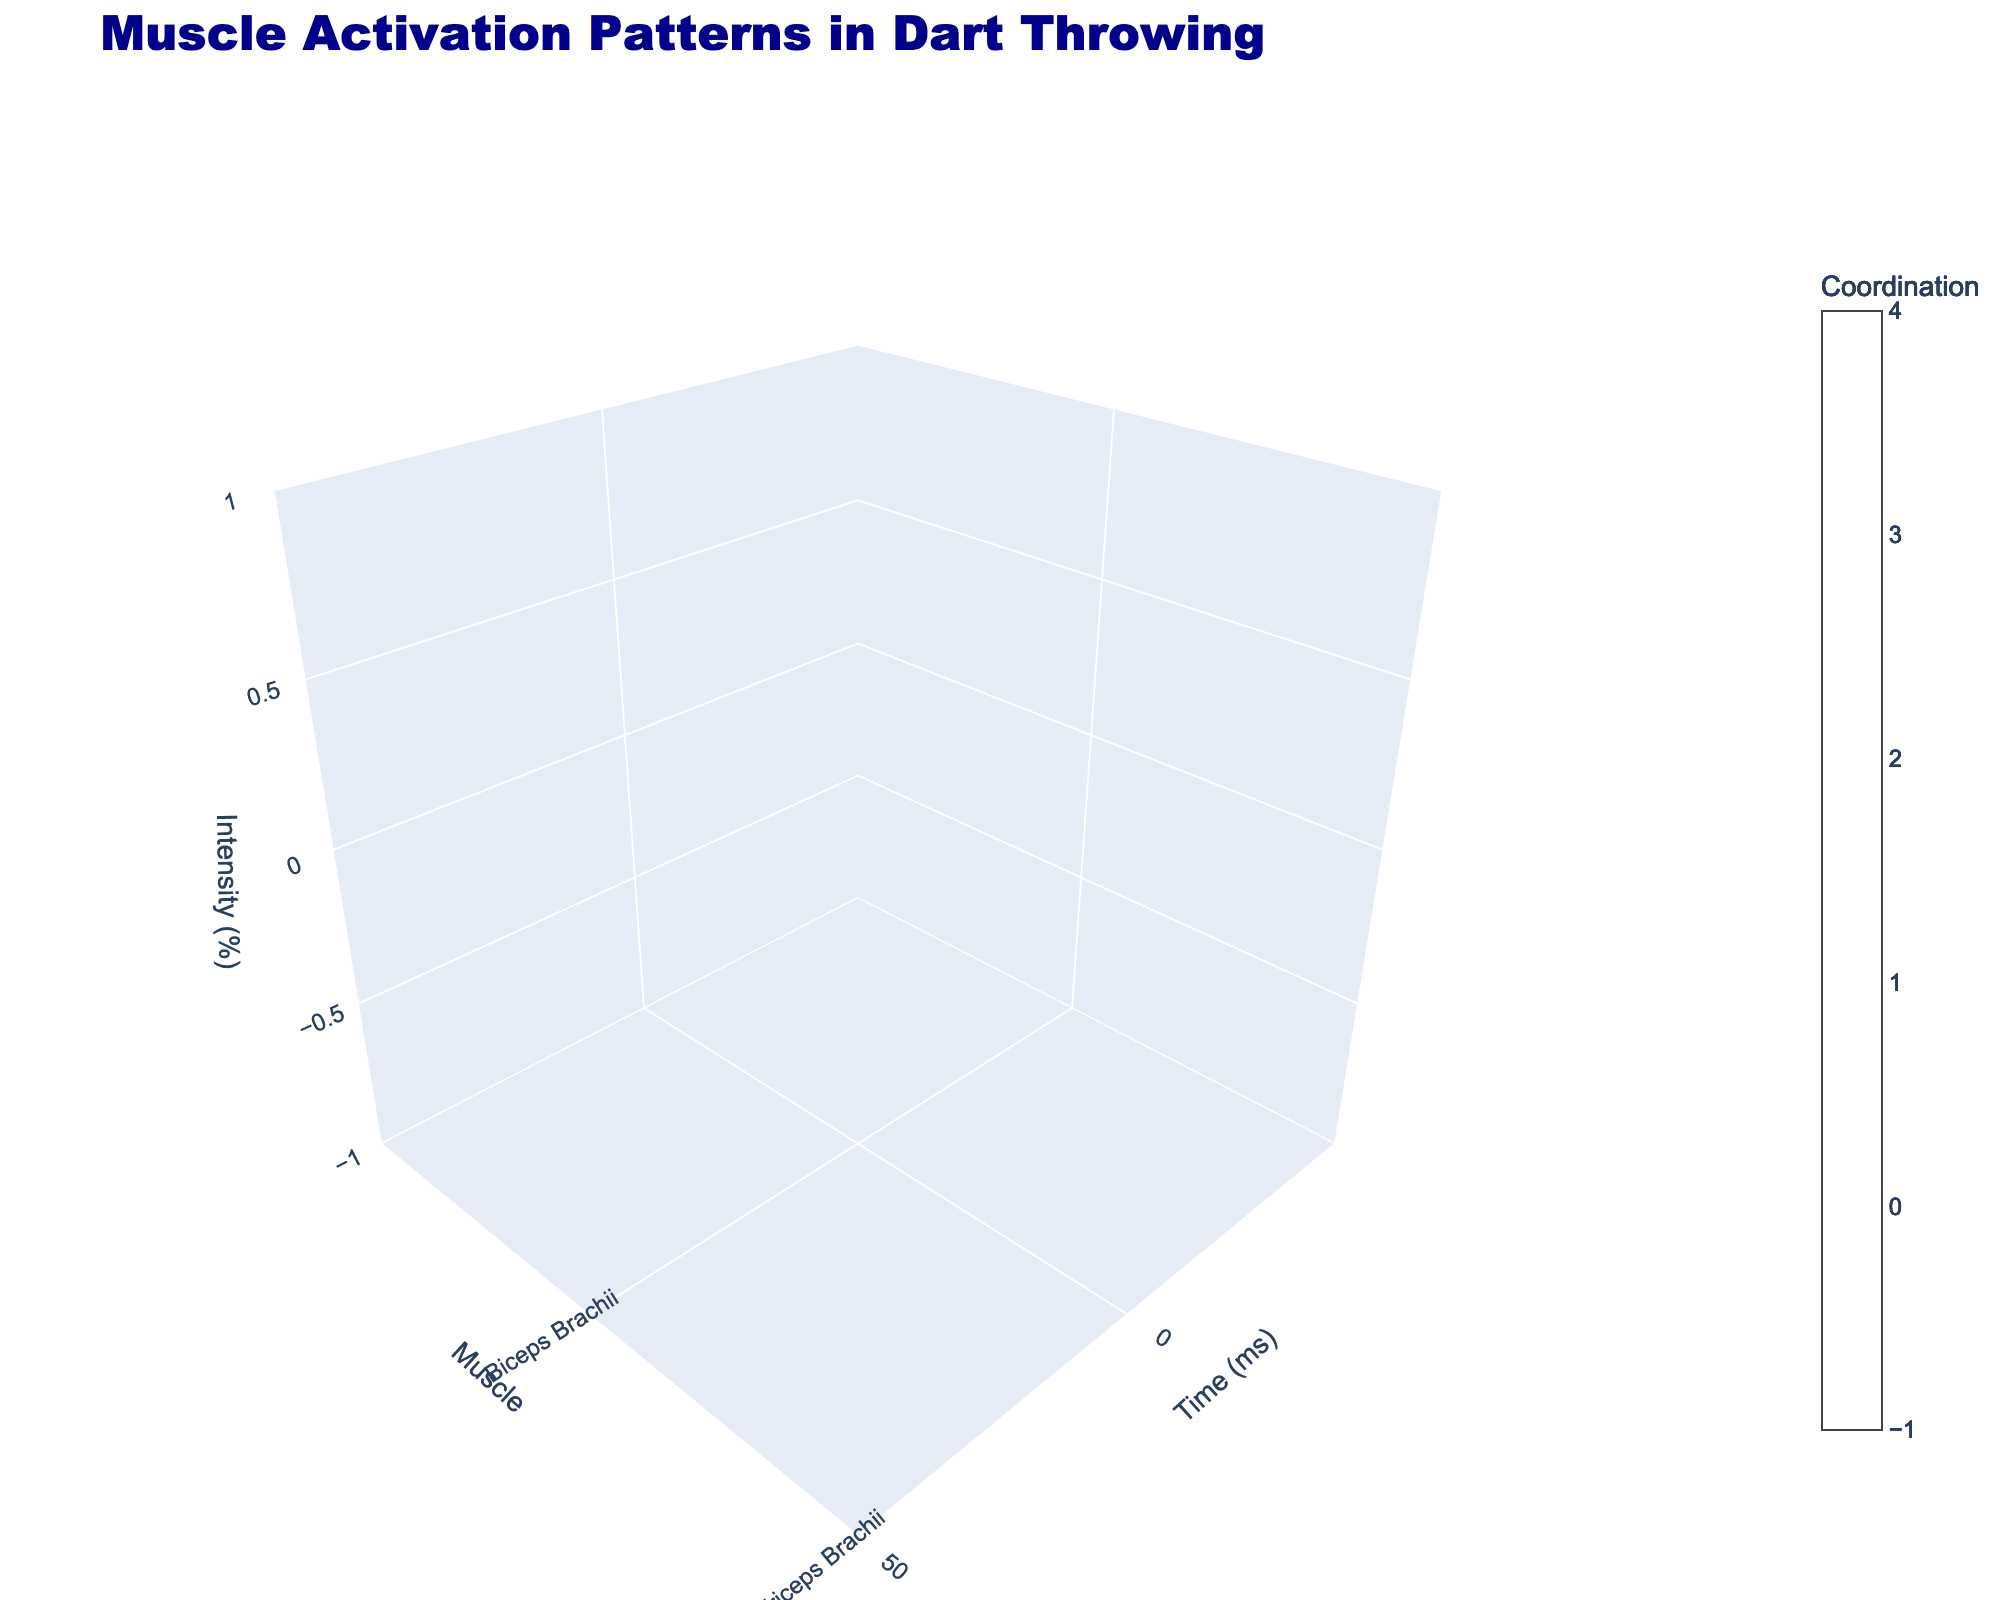What is the title of the figure? The title is usually located at the top of the figure. By reading it, we can quickly identify the visual theme of the plot. In this case, the title specified in the code indicates the main focus of the data being displayed.
Answer: Muscle Activation Patterns in Dart Throwing How many different muscles are analyzed in the figure? We can determine the number of different muscles by looking at the Y-axis, which lists the unique muscle names. Each distinct name represents a different muscle being analyzed.
Answer: 4 Which muscle shows the highest intensity at 100 ms? To answer this, we need to compare the height of the bars or volume corresponding to the 100 ms mark along the X-axis for each muscle. The muscle with the tallest bar at this point has the highest intensity.
Answer: Brachioradialis How does the coordination value of the Triceps Brachii change from 0 ms to 200 ms? By looking at the color gradients on the plot for the Triceps Brachii over time, we can observe how the color changes and thus how the coordination value evolves. Higher coordination values correspond to more red-shaded colors, while lower values tend to be blue or green.
Answer: Increases first and then decreases Arrange the muscles in order of peak intensity values reached during the dart throw. We need to find the highest points on the Z-axis for each muscle and then sort them from highest to lowest. This involves checking the tallest bars within each muscle category.
Answer: Brachioradialis, Triceps Brachii, Deltoid, Biceps Brachii What is the intensity percentage for the Deltoid muscle at 150 ms? To determine this, we need to locate the point on the Deltoid muscle's line at the 150 ms mark on the X-axis and note the value on the Z-axis.
Answer: 95% Which muscle exhibits the most consistently high coordination values throughout the throw? Observing the color gradient for each muscle across all time points, the muscle with the consistently red-colored bars will have the highest coordination values consistently.
Answer: Deltoid Compare the muscle activation patterns of Biceps Brachii and Triceps Brachii at 50 ms. Which one has higher intensity and coordination? Look at both Biceps Brachii and Triceps Brachii at the 50 ms mark along the X-axis, then compare the Z-axis heights and the shades of color representing their coordination values.
Answer: Triceps Brachii At what time(s) do the Brachioradialis and Deltoid muscles have equal intensity levels? Track the Z-axis values for both muscles over various time points and identify any coinciding values. Analyzing each time mark, we note when the heights match.
Answer: Never 